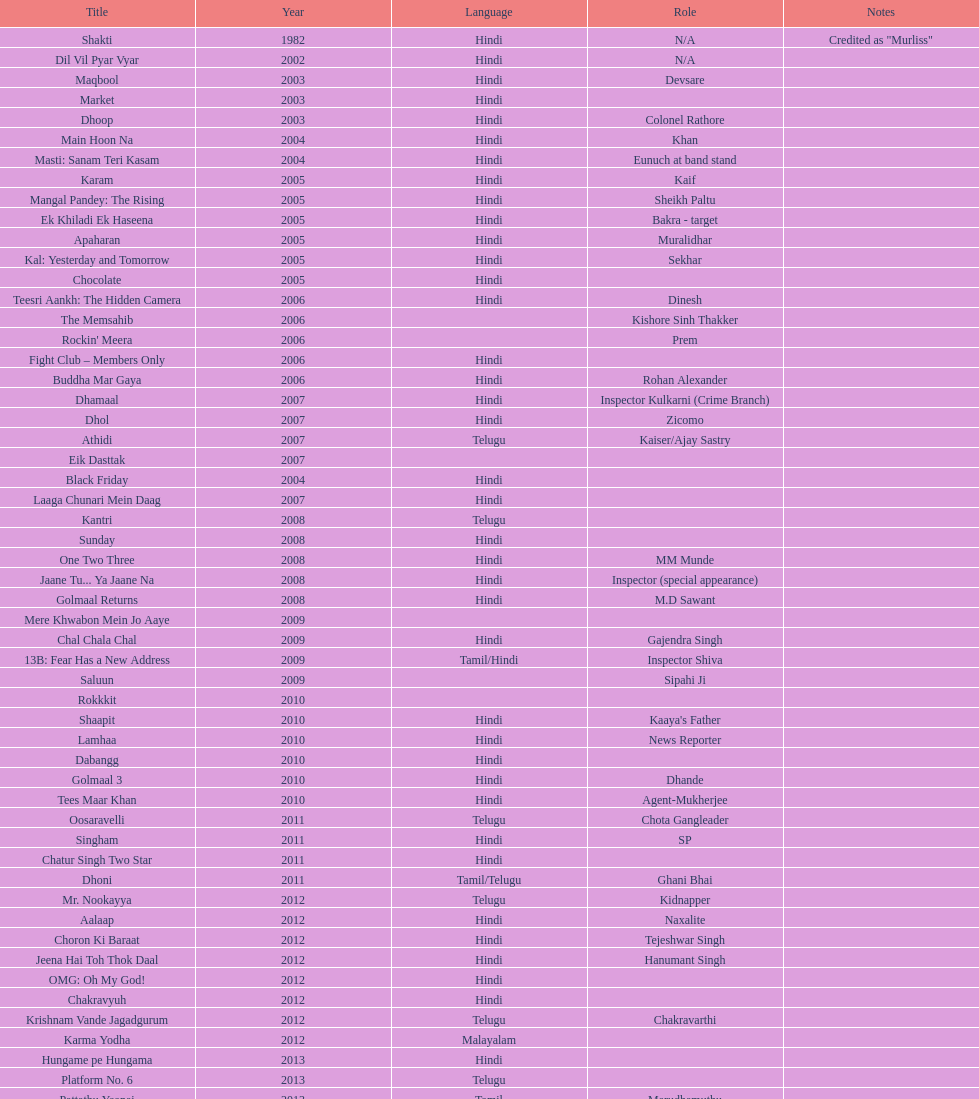Is the note duration in maqbool greater than in shakti? No. 